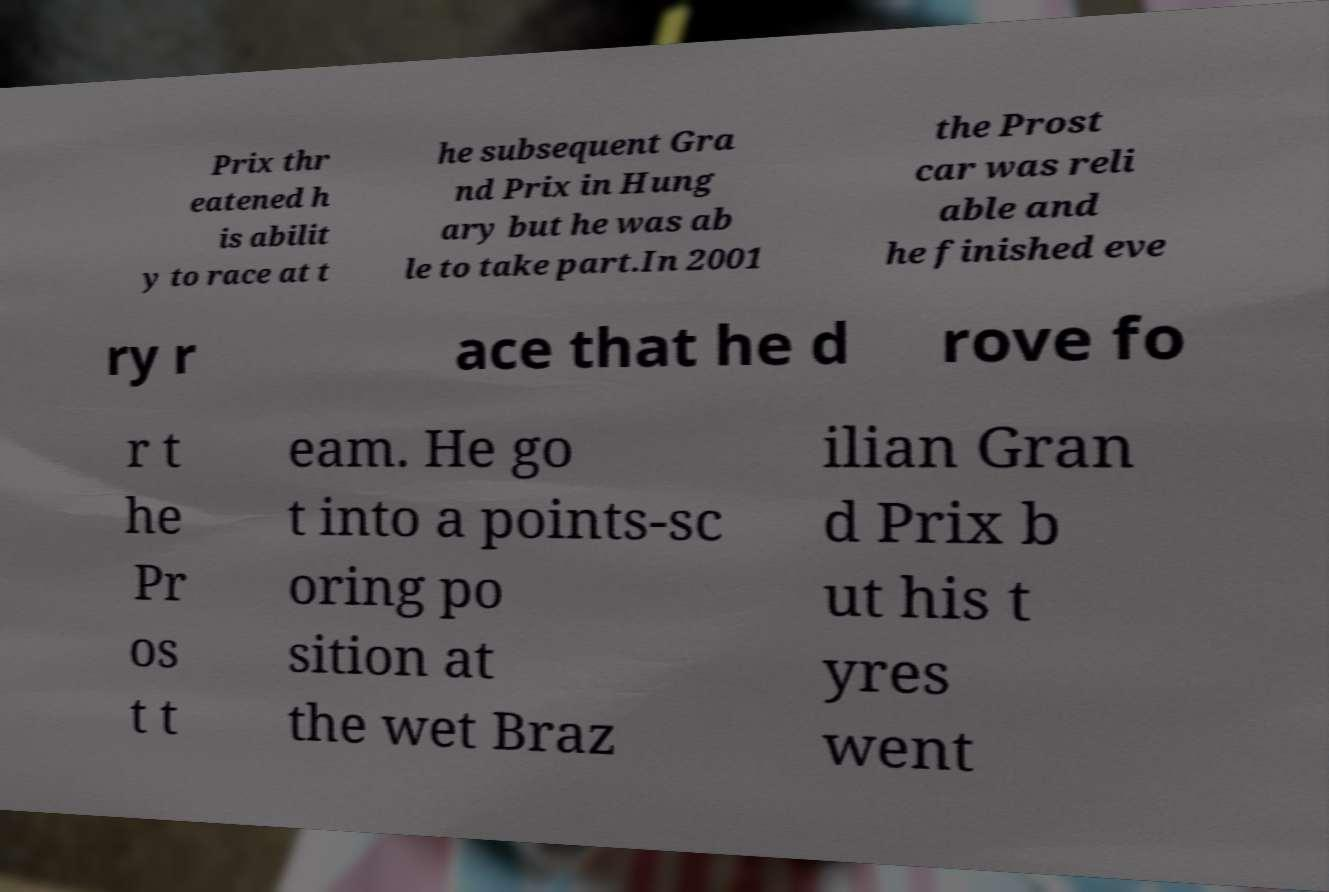Can you read and provide the text displayed in the image?This photo seems to have some interesting text. Can you extract and type it out for me? Prix thr eatened h is abilit y to race at t he subsequent Gra nd Prix in Hung ary but he was ab le to take part.In 2001 the Prost car was reli able and he finished eve ry r ace that he d rove fo r t he Pr os t t eam. He go t into a points-sc oring po sition at the wet Braz ilian Gran d Prix b ut his t yres went 